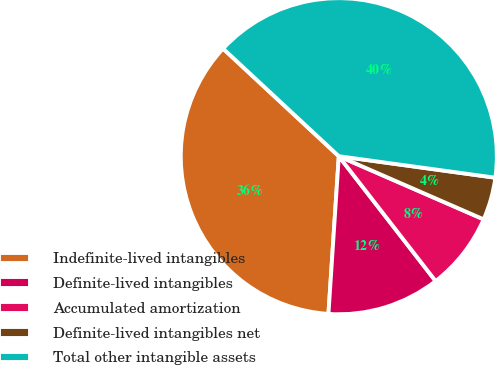Convert chart to OTSL. <chart><loc_0><loc_0><loc_500><loc_500><pie_chart><fcel>Indefinite-lived intangibles<fcel>Definite-lived intangibles<fcel>Accumulated amortization<fcel>Definite-lived intangibles net<fcel>Total other intangible assets<nl><fcel>35.88%<fcel>11.54%<fcel>7.96%<fcel>4.37%<fcel>40.25%<nl></chart> 